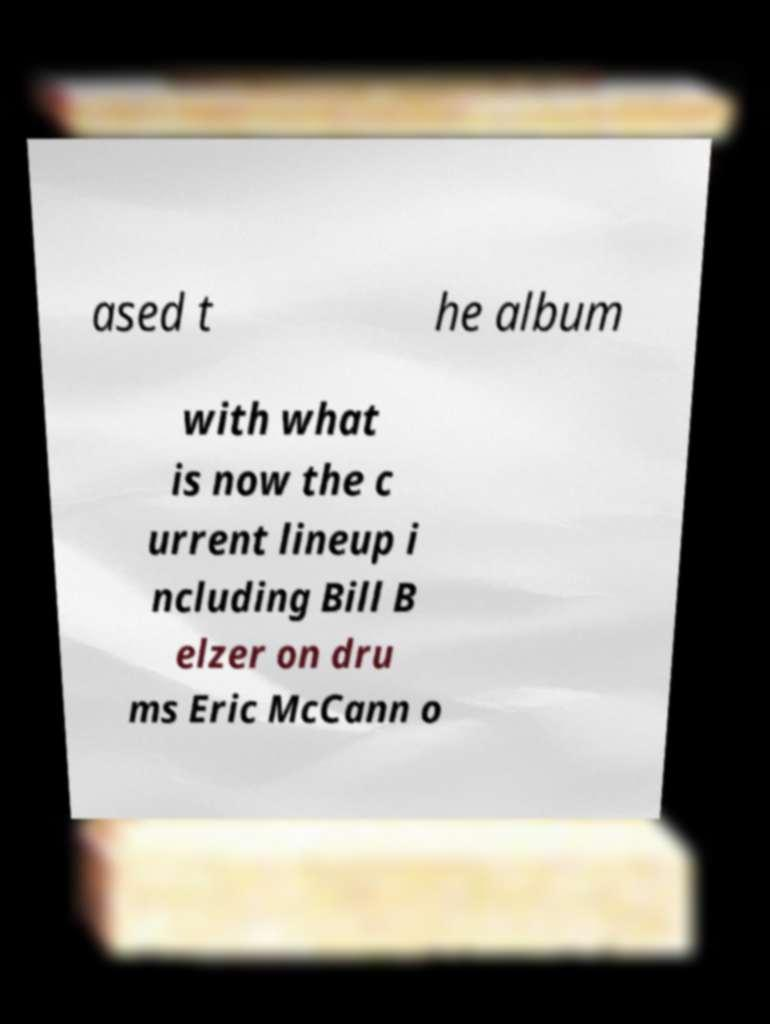Please read and relay the text visible in this image. What does it say? ased t he album with what is now the c urrent lineup i ncluding Bill B elzer on dru ms Eric McCann o 